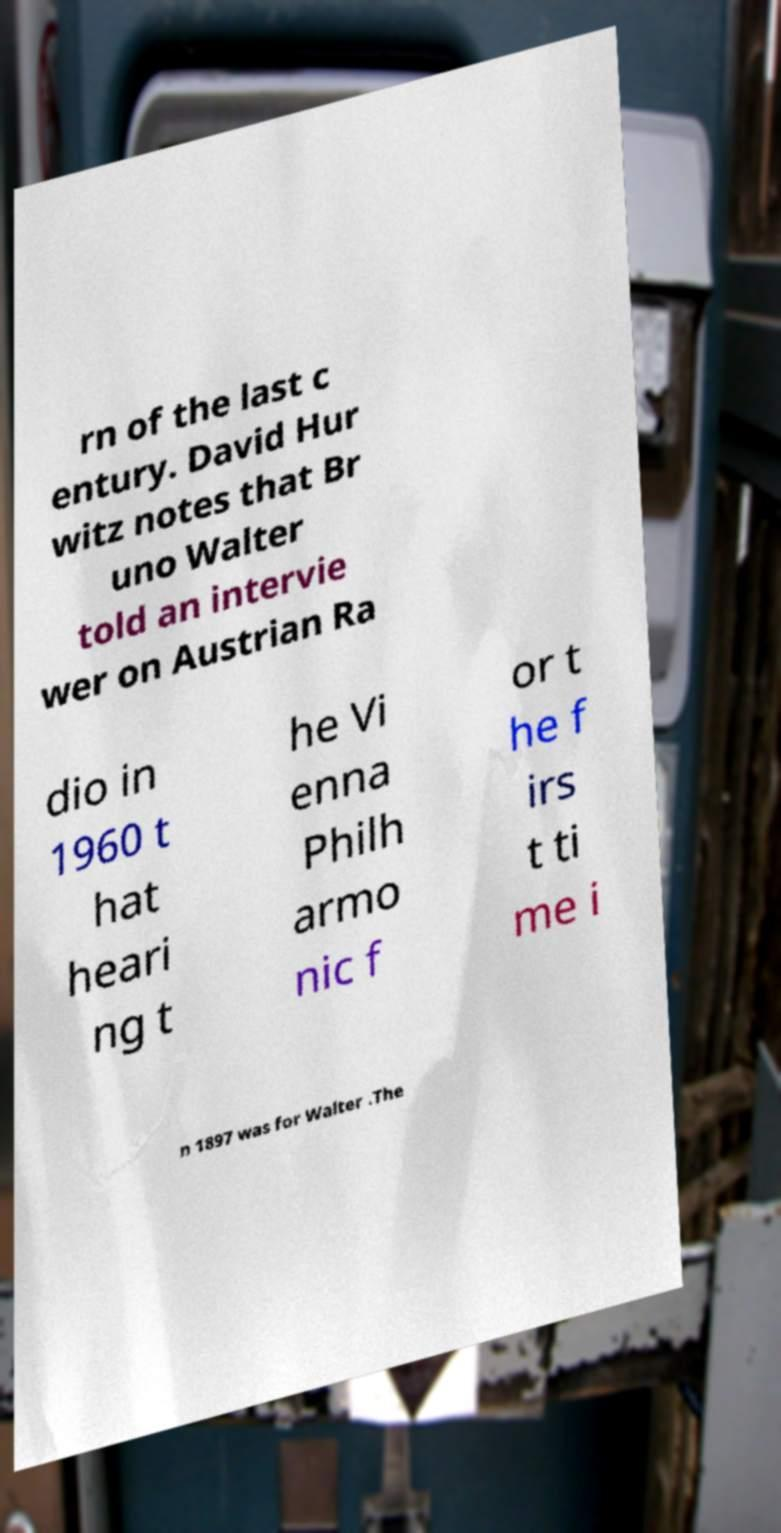Could you extract and type out the text from this image? rn of the last c entury. David Hur witz notes that Br uno Walter told an intervie wer on Austrian Ra dio in 1960 t hat heari ng t he Vi enna Philh armo nic f or t he f irs t ti me i n 1897 was for Walter .The 